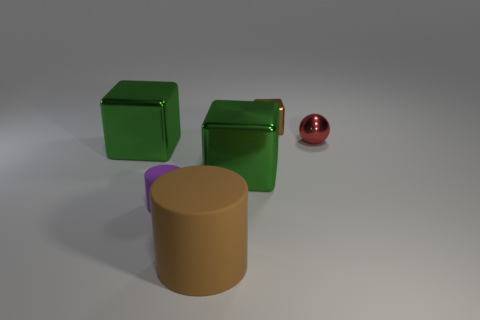Does the brown metal thing have the same size as the green metal block to the left of the big brown cylinder?
Provide a succinct answer. No. Is the size of the brown cube the same as the brown matte thing?
Provide a succinct answer. No. The brown rubber object has what size?
Provide a succinct answer. Large. Is the number of cylinders that are right of the purple object greater than the number of purple objects that are behind the tiny brown shiny cube?
Give a very brief answer. Yes. Is the number of cylinders greater than the number of blocks?
Offer a terse response. No. There is a metal cube that is right of the brown cylinder and in front of the brown block; how big is it?
Provide a short and direct response. Large. There is a large matte thing; what shape is it?
Keep it short and to the point. Cylinder. Are there more small brown things that are behind the large brown object than small gray cylinders?
Make the answer very short. Yes. There is a big thing behind the shiny cube that is in front of the big metal thing left of the big brown thing; what shape is it?
Offer a very short reply. Cube. Does the object that is behind the red sphere have the same size as the red thing?
Make the answer very short. Yes. 